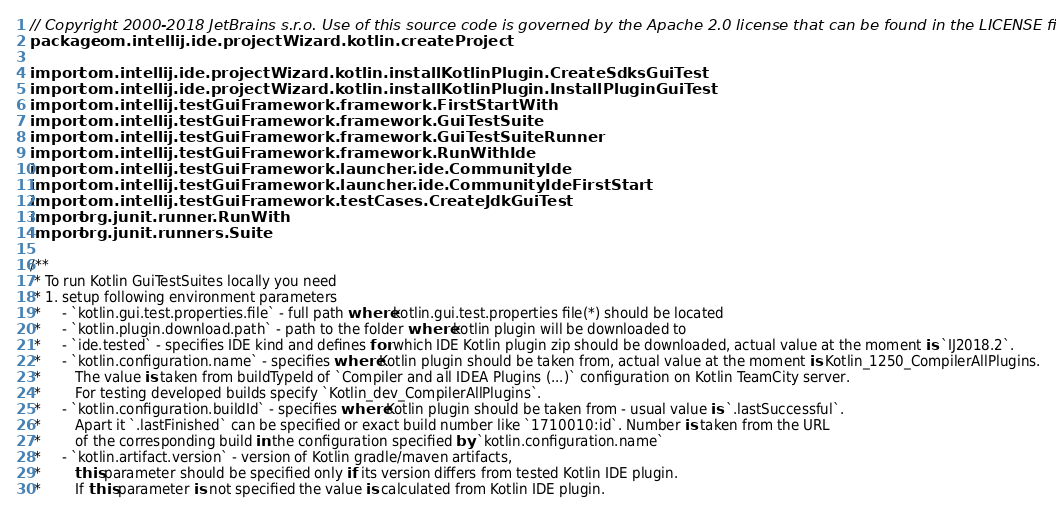Convert code to text. <code><loc_0><loc_0><loc_500><loc_500><_Kotlin_>// Copyright 2000-2018 JetBrains s.r.o. Use of this source code is governed by the Apache 2.0 license that can be found in the LICENSE file.
package com.intellij.ide.projectWizard.kotlin.createProject

import com.intellij.ide.projectWizard.kotlin.installKotlinPlugin.CreateSdksGuiTest
import com.intellij.ide.projectWizard.kotlin.installKotlinPlugin.InstallPluginGuiTest
import com.intellij.testGuiFramework.framework.FirstStartWith
import com.intellij.testGuiFramework.framework.GuiTestSuite
import com.intellij.testGuiFramework.framework.GuiTestSuiteRunner
import com.intellij.testGuiFramework.framework.RunWithIde
import com.intellij.testGuiFramework.launcher.ide.CommunityIde
import com.intellij.testGuiFramework.launcher.ide.CommunityIdeFirstStart
import com.intellij.testGuiFramework.testCases.CreateJdkGuiTest
import org.junit.runner.RunWith
import org.junit.runners.Suite

/**
 * To run Kotlin GuiTestSuites locally you need
 * 1. setup following environment parameters
 *     - `kotlin.gui.test.properties.file` - full path where kotlin.gui.test.properties file(*) should be located
 *     - `kotlin.plugin.download.path` - path to the folder where kotlin plugin will be downloaded to
 *     - `ide.tested` - specifies IDE kind and defines for which IDE Kotlin plugin zip should be downloaded, actual value at the moment is `IJ2018.2`.
 *     - `kotlin.configuration.name` - specifies where Kotlin plugin should be taken from, actual value at the moment is Kotlin_1250_CompilerAllPlugins.
 *        The value is taken from buildTypeId of `Compiler and all IDEA Plugins (...)` configuration on Kotlin TeamCity server.
 *        For testing developed builds specify `Kotlin_dev_CompilerAllPlugins`.
 *     - `kotlin.configuration.buildId` - specifies where Kotlin plugin should be taken from - usual value is `.lastSuccessful`.
 *        Apart it `.lastFinished` can be specified or exact build number like `1710010:id`. Number is taken from the URL
 *        of the corresponding build in the configuration specified by `kotlin.configuration.name`
 *     - `kotlin.artifact.version` - version of Kotlin gradle/maven artifacts,
 *        this parameter should be specified only if its version differs from tested Kotlin IDE plugin.
 *        If this parameter is not specified the value is calculated from Kotlin IDE plugin.</code> 